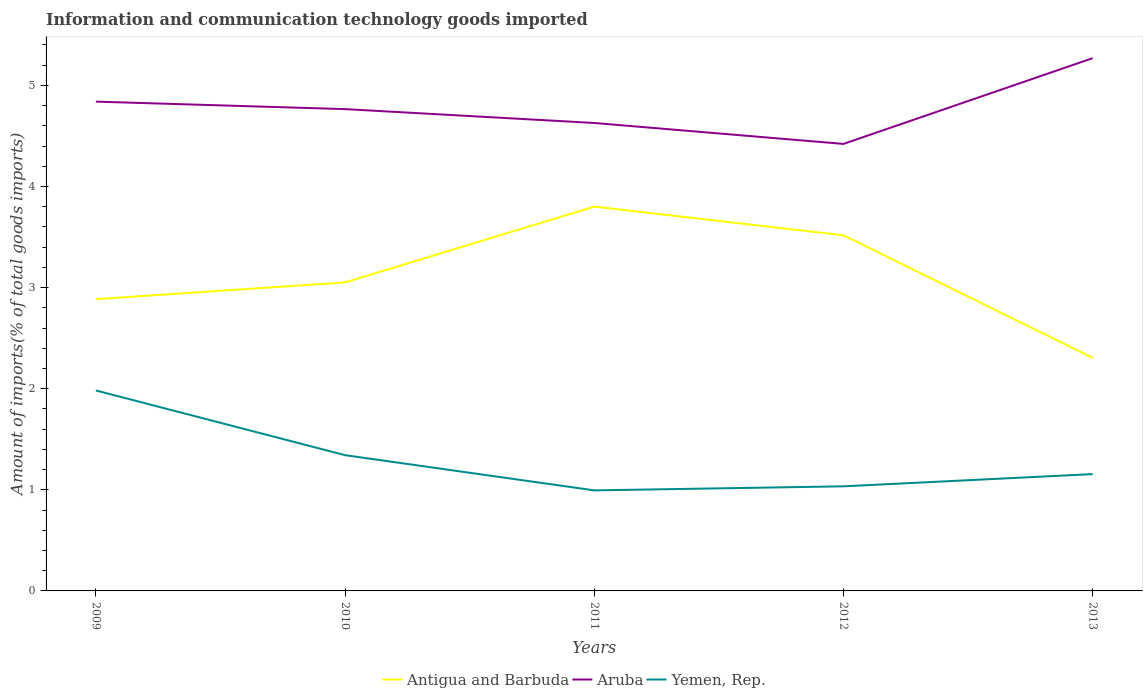Across all years, what is the maximum amount of goods imported in Yemen, Rep.?
Your answer should be very brief. 0.99. In which year was the amount of goods imported in Antigua and Barbuda maximum?
Offer a terse response. 2013. What is the total amount of goods imported in Aruba in the graph?
Make the answer very short. 0.14. What is the difference between the highest and the second highest amount of goods imported in Yemen, Rep.?
Ensure brevity in your answer.  0.99. Are the values on the major ticks of Y-axis written in scientific E-notation?
Provide a succinct answer. No. Does the graph contain grids?
Provide a succinct answer. No. How are the legend labels stacked?
Your response must be concise. Horizontal. What is the title of the graph?
Keep it short and to the point. Information and communication technology goods imported. Does "Iraq" appear as one of the legend labels in the graph?
Give a very brief answer. No. What is the label or title of the Y-axis?
Your answer should be very brief. Amount of imports(% of total goods imports). What is the Amount of imports(% of total goods imports) of Antigua and Barbuda in 2009?
Keep it short and to the point. 2.89. What is the Amount of imports(% of total goods imports) in Aruba in 2009?
Offer a very short reply. 4.84. What is the Amount of imports(% of total goods imports) in Yemen, Rep. in 2009?
Give a very brief answer. 1.98. What is the Amount of imports(% of total goods imports) of Antigua and Barbuda in 2010?
Offer a very short reply. 3.05. What is the Amount of imports(% of total goods imports) of Aruba in 2010?
Your response must be concise. 4.76. What is the Amount of imports(% of total goods imports) in Yemen, Rep. in 2010?
Offer a terse response. 1.34. What is the Amount of imports(% of total goods imports) in Antigua and Barbuda in 2011?
Give a very brief answer. 3.8. What is the Amount of imports(% of total goods imports) in Aruba in 2011?
Offer a very short reply. 4.63. What is the Amount of imports(% of total goods imports) in Yemen, Rep. in 2011?
Your answer should be compact. 0.99. What is the Amount of imports(% of total goods imports) of Antigua and Barbuda in 2012?
Offer a terse response. 3.52. What is the Amount of imports(% of total goods imports) of Aruba in 2012?
Your answer should be very brief. 4.42. What is the Amount of imports(% of total goods imports) of Yemen, Rep. in 2012?
Offer a very short reply. 1.03. What is the Amount of imports(% of total goods imports) in Antigua and Barbuda in 2013?
Give a very brief answer. 2.31. What is the Amount of imports(% of total goods imports) of Aruba in 2013?
Offer a terse response. 5.27. What is the Amount of imports(% of total goods imports) in Yemen, Rep. in 2013?
Provide a succinct answer. 1.16. Across all years, what is the maximum Amount of imports(% of total goods imports) of Antigua and Barbuda?
Provide a succinct answer. 3.8. Across all years, what is the maximum Amount of imports(% of total goods imports) of Aruba?
Give a very brief answer. 5.27. Across all years, what is the maximum Amount of imports(% of total goods imports) of Yemen, Rep.?
Your answer should be very brief. 1.98. Across all years, what is the minimum Amount of imports(% of total goods imports) in Antigua and Barbuda?
Provide a short and direct response. 2.31. Across all years, what is the minimum Amount of imports(% of total goods imports) of Aruba?
Your response must be concise. 4.42. Across all years, what is the minimum Amount of imports(% of total goods imports) in Yemen, Rep.?
Your answer should be very brief. 0.99. What is the total Amount of imports(% of total goods imports) of Antigua and Barbuda in the graph?
Provide a succinct answer. 15.56. What is the total Amount of imports(% of total goods imports) of Aruba in the graph?
Offer a terse response. 23.92. What is the total Amount of imports(% of total goods imports) in Yemen, Rep. in the graph?
Ensure brevity in your answer.  6.51. What is the difference between the Amount of imports(% of total goods imports) of Antigua and Barbuda in 2009 and that in 2010?
Your answer should be very brief. -0.17. What is the difference between the Amount of imports(% of total goods imports) of Aruba in 2009 and that in 2010?
Your answer should be compact. 0.07. What is the difference between the Amount of imports(% of total goods imports) in Yemen, Rep. in 2009 and that in 2010?
Your response must be concise. 0.64. What is the difference between the Amount of imports(% of total goods imports) in Antigua and Barbuda in 2009 and that in 2011?
Your answer should be very brief. -0.92. What is the difference between the Amount of imports(% of total goods imports) of Aruba in 2009 and that in 2011?
Offer a terse response. 0.21. What is the difference between the Amount of imports(% of total goods imports) in Antigua and Barbuda in 2009 and that in 2012?
Your answer should be very brief. -0.63. What is the difference between the Amount of imports(% of total goods imports) in Aruba in 2009 and that in 2012?
Your answer should be very brief. 0.42. What is the difference between the Amount of imports(% of total goods imports) of Yemen, Rep. in 2009 and that in 2012?
Give a very brief answer. 0.95. What is the difference between the Amount of imports(% of total goods imports) in Antigua and Barbuda in 2009 and that in 2013?
Your response must be concise. 0.58. What is the difference between the Amount of imports(% of total goods imports) in Aruba in 2009 and that in 2013?
Your response must be concise. -0.43. What is the difference between the Amount of imports(% of total goods imports) in Yemen, Rep. in 2009 and that in 2013?
Your answer should be very brief. 0.83. What is the difference between the Amount of imports(% of total goods imports) in Antigua and Barbuda in 2010 and that in 2011?
Keep it short and to the point. -0.75. What is the difference between the Amount of imports(% of total goods imports) in Aruba in 2010 and that in 2011?
Ensure brevity in your answer.  0.14. What is the difference between the Amount of imports(% of total goods imports) in Yemen, Rep. in 2010 and that in 2011?
Provide a succinct answer. 0.35. What is the difference between the Amount of imports(% of total goods imports) in Antigua and Barbuda in 2010 and that in 2012?
Give a very brief answer. -0.47. What is the difference between the Amount of imports(% of total goods imports) of Aruba in 2010 and that in 2012?
Your response must be concise. 0.34. What is the difference between the Amount of imports(% of total goods imports) of Yemen, Rep. in 2010 and that in 2012?
Provide a succinct answer. 0.31. What is the difference between the Amount of imports(% of total goods imports) in Antigua and Barbuda in 2010 and that in 2013?
Offer a very short reply. 0.75. What is the difference between the Amount of imports(% of total goods imports) in Aruba in 2010 and that in 2013?
Your answer should be compact. -0.5. What is the difference between the Amount of imports(% of total goods imports) of Yemen, Rep. in 2010 and that in 2013?
Provide a succinct answer. 0.19. What is the difference between the Amount of imports(% of total goods imports) of Antigua and Barbuda in 2011 and that in 2012?
Offer a very short reply. 0.28. What is the difference between the Amount of imports(% of total goods imports) of Aruba in 2011 and that in 2012?
Your answer should be compact. 0.21. What is the difference between the Amount of imports(% of total goods imports) in Yemen, Rep. in 2011 and that in 2012?
Provide a succinct answer. -0.04. What is the difference between the Amount of imports(% of total goods imports) in Antigua and Barbuda in 2011 and that in 2013?
Offer a terse response. 1.5. What is the difference between the Amount of imports(% of total goods imports) in Aruba in 2011 and that in 2013?
Provide a succinct answer. -0.64. What is the difference between the Amount of imports(% of total goods imports) of Yemen, Rep. in 2011 and that in 2013?
Provide a succinct answer. -0.16. What is the difference between the Amount of imports(% of total goods imports) of Antigua and Barbuda in 2012 and that in 2013?
Your answer should be very brief. 1.21. What is the difference between the Amount of imports(% of total goods imports) of Aruba in 2012 and that in 2013?
Provide a succinct answer. -0.85. What is the difference between the Amount of imports(% of total goods imports) in Yemen, Rep. in 2012 and that in 2013?
Make the answer very short. -0.12. What is the difference between the Amount of imports(% of total goods imports) of Antigua and Barbuda in 2009 and the Amount of imports(% of total goods imports) of Aruba in 2010?
Provide a succinct answer. -1.88. What is the difference between the Amount of imports(% of total goods imports) of Antigua and Barbuda in 2009 and the Amount of imports(% of total goods imports) of Yemen, Rep. in 2010?
Provide a short and direct response. 1.54. What is the difference between the Amount of imports(% of total goods imports) of Aruba in 2009 and the Amount of imports(% of total goods imports) of Yemen, Rep. in 2010?
Offer a terse response. 3.5. What is the difference between the Amount of imports(% of total goods imports) of Antigua and Barbuda in 2009 and the Amount of imports(% of total goods imports) of Aruba in 2011?
Your answer should be very brief. -1.74. What is the difference between the Amount of imports(% of total goods imports) in Antigua and Barbuda in 2009 and the Amount of imports(% of total goods imports) in Yemen, Rep. in 2011?
Offer a terse response. 1.89. What is the difference between the Amount of imports(% of total goods imports) of Aruba in 2009 and the Amount of imports(% of total goods imports) of Yemen, Rep. in 2011?
Your answer should be very brief. 3.84. What is the difference between the Amount of imports(% of total goods imports) in Antigua and Barbuda in 2009 and the Amount of imports(% of total goods imports) in Aruba in 2012?
Your answer should be compact. -1.54. What is the difference between the Amount of imports(% of total goods imports) in Antigua and Barbuda in 2009 and the Amount of imports(% of total goods imports) in Yemen, Rep. in 2012?
Give a very brief answer. 1.85. What is the difference between the Amount of imports(% of total goods imports) of Aruba in 2009 and the Amount of imports(% of total goods imports) of Yemen, Rep. in 2012?
Offer a very short reply. 3.8. What is the difference between the Amount of imports(% of total goods imports) in Antigua and Barbuda in 2009 and the Amount of imports(% of total goods imports) in Aruba in 2013?
Offer a very short reply. -2.38. What is the difference between the Amount of imports(% of total goods imports) of Antigua and Barbuda in 2009 and the Amount of imports(% of total goods imports) of Yemen, Rep. in 2013?
Your answer should be very brief. 1.73. What is the difference between the Amount of imports(% of total goods imports) of Aruba in 2009 and the Amount of imports(% of total goods imports) of Yemen, Rep. in 2013?
Provide a short and direct response. 3.68. What is the difference between the Amount of imports(% of total goods imports) of Antigua and Barbuda in 2010 and the Amount of imports(% of total goods imports) of Aruba in 2011?
Ensure brevity in your answer.  -1.58. What is the difference between the Amount of imports(% of total goods imports) of Antigua and Barbuda in 2010 and the Amount of imports(% of total goods imports) of Yemen, Rep. in 2011?
Offer a very short reply. 2.06. What is the difference between the Amount of imports(% of total goods imports) in Aruba in 2010 and the Amount of imports(% of total goods imports) in Yemen, Rep. in 2011?
Ensure brevity in your answer.  3.77. What is the difference between the Amount of imports(% of total goods imports) in Antigua and Barbuda in 2010 and the Amount of imports(% of total goods imports) in Aruba in 2012?
Make the answer very short. -1.37. What is the difference between the Amount of imports(% of total goods imports) in Antigua and Barbuda in 2010 and the Amount of imports(% of total goods imports) in Yemen, Rep. in 2012?
Offer a terse response. 2.02. What is the difference between the Amount of imports(% of total goods imports) in Aruba in 2010 and the Amount of imports(% of total goods imports) in Yemen, Rep. in 2012?
Your response must be concise. 3.73. What is the difference between the Amount of imports(% of total goods imports) of Antigua and Barbuda in 2010 and the Amount of imports(% of total goods imports) of Aruba in 2013?
Offer a very short reply. -2.22. What is the difference between the Amount of imports(% of total goods imports) in Antigua and Barbuda in 2010 and the Amount of imports(% of total goods imports) in Yemen, Rep. in 2013?
Offer a terse response. 1.9. What is the difference between the Amount of imports(% of total goods imports) in Aruba in 2010 and the Amount of imports(% of total goods imports) in Yemen, Rep. in 2013?
Your answer should be compact. 3.61. What is the difference between the Amount of imports(% of total goods imports) in Antigua and Barbuda in 2011 and the Amount of imports(% of total goods imports) in Aruba in 2012?
Ensure brevity in your answer.  -0.62. What is the difference between the Amount of imports(% of total goods imports) in Antigua and Barbuda in 2011 and the Amount of imports(% of total goods imports) in Yemen, Rep. in 2012?
Ensure brevity in your answer.  2.77. What is the difference between the Amount of imports(% of total goods imports) of Aruba in 2011 and the Amount of imports(% of total goods imports) of Yemen, Rep. in 2012?
Your answer should be very brief. 3.59. What is the difference between the Amount of imports(% of total goods imports) of Antigua and Barbuda in 2011 and the Amount of imports(% of total goods imports) of Aruba in 2013?
Your answer should be compact. -1.47. What is the difference between the Amount of imports(% of total goods imports) of Antigua and Barbuda in 2011 and the Amount of imports(% of total goods imports) of Yemen, Rep. in 2013?
Offer a very short reply. 2.65. What is the difference between the Amount of imports(% of total goods imports) in Aruba in 2011 and the Amount of imports(% of total goods imports) in Yemen, Rep. in 2013?
Ensure brevity in your answer.  3.47. What is the difference between the Amount of imports(% of total goods imports) in Antigua and Barbuda in 2012 and the Amount of imports(% of total goods imports) in Aruba in 2013?
Ensure brevity in your answer.  -1.75. What is the difference between the Amount of imports(% of total goods imports) in Antigua and Barbuda in 2012 and the Amount of imports(% of total goods imports) in Yemen, Rep. in 2013?
Give a very brief answer. 2.36. What is the difference between the Amount of imports(% of total goods imports) of Aruba in 2012 and the Amount of imports(% of total goods imports) of Yemen, Rep. in 2013?
Give a very brief answer. 3.27. What is the average Amount of imports(% of total goods imports) of Antigua and Barbuda per year?
Ensure brevity in your answer.  3.11. What is the average Amount of imports(% of total goods imports) in Aruba per year?
Offer a terse response. 4.78. What is the average Amount of imports(% of total goods imports) in Yemen, Rep. per year?
Provide a short and direct response. 1.3. In the year 2009, what is the difference between the Amount of imports(% of total goods imports) in Antigua and Barbuda and Amount of imports(% of total goods imports) in Aruba?
Your response must be concise. -1.95. In the year 2009, what is the difference between the Amount of imports(% of total goods imports) in Antigua and Barbuda and Amount of imports(% of total goods imports) in Yemen, Rep.?
Offer a terse response. 0.9. In the year 2009, what is the difference between the Amount of imports(% of total goods imports) in Aruba and Amount of imports(% of total goods imports) in Yemen, Rep.?
Your response must be concise. 2.86. In the year 2010, what is the difference between the Amount of imports(% of total goods imports) in Antigua and Barbuda and Amount of imports(% of total goods imports) in Aruba?
Provide a short and direct response. -1.71. In the year 2010, what is the difference between the Amount of imports(% of total goods imports) in Antigua and Barbuda and Amount of imports(% of total goods imports) in Yemen, Rep.?
Keep it short and to the point. 1.71. In the year 2010, what is the difference between the Amount of imports(% of total goods imports) of Aruba and Amount of imports(% of total goods imports) of Yemen, Rep.?
Provide a succinct answer. 3.42. In the year 2011, what is the difference between the Amount of imports(% of total goods imports) in Antigua and Barbuda and Amount of imports(% of total goods imports) in Aruba?
Make the answer very short. -0.83. In the year 2011, what is the difference between the Amount of imports(% of total goods imports) in Antigua and Barbuda and Amount of imports(% of total goods imports) in Yemen, Rep.?
Keep it short and to the point. 2.81. In the year 2011, what is the difference between the Amount of imports(% of total goods imports) in Aruba and Amount of imports(% of total goods imports) in Yemen, Rep.?
Offer a very short reply. 3.63. In the year 2012, what is the difference between the Amount of imports(% of total goods imports) in Antigua and Barbuda and Amount of imports(% of total goods imports) in Aruba?
Provide a succinct answer. -0.9. In the year 2012, what is the difference between the Amount of imports(% of total goods imports) in Antigua and Barbuda and Amount of imports(% of total goods imports) in Yemen, Rep.?
Ensure brevity in your answer.  2.48. In the year 2012, what is the difference between the Amount of imports(% of total goods imports) in Aruba and Amount of imports(% of total goods imports) in Yemen, Rep.?
Offer a terse response. 3.39. In the year 2013, what is the difference between the Amount of imports(% of total goods imports) in Antigua and Barbuda and Amount of imports(% of total goods imports) in Aruba?
Your response must be concise. -2.96. In the year 2013, what is the difference between the Amount of imports(% of total goods imports) of Antigua and Barbuda and Amount of imports(% of total goods imports) of Yemen, Rep.?
Offer a very short reply. 1.15. In the year 2013, what is the difference between the Amount of imports(% of total goods imports) in Aruba and Amount of imports(% of total goods imports) in Yemen, Rep.?
Offer a very short reply. 4.11. What is the ratio of the Amount of imports(% of total goods imports) in Antigua and Barbuda in 2009 to that in 2010?
Keep it short and to the point. 0.95. What is the ratio of the Amount of imports(% of total goods imports) of Aruba in 2009 to that in 2010?
Keep it short and to the point. 1.02. What is the ratio of the Amount of imports(% of total goods imports) of Yemen, Rep. in 2009 to that in 2010?
Your answer should be very brief. 1.48. What is the ratio of the Amount of imports(% of total goods imports) of Antigua and Barbuda in 2009 to that in 2011?
Your response must be concise. 0.76. What is the ratio of the Amount of imports(% of total goods imports) of Aruba in 2009 to that in 2011?
Provide a short and direct response. 1.05. What is the ratio of the Amount of imports(% of total goods imports) in Yemen, Rep. in 2009 to that in 2011?
Offer a very short reply. 1.99. What is the ratio of the Amount of imports(% of total goods imports) of Antigua and Barbuda in 2009 to that in 2012?
Offer a terse response. 0.82. What is the ratio of the Amount of imports(% of total goods imports) in Aruba in 2009 to that in 2012?
Give a very brief answer. 1.09. What is the ratio of the Amount of imports(% of total goods imports) in Yemen, Rep. in 2009 to that in 2012?
Ensure brevity in your answer.  1.92. What is the ratio of the Amount of imports(% of total goods imports) in Antigua and Barbuda in 2009 to that in 2013?
Offer a very short reply. 1.25. What is the ratio of the Amount of imports(% of total goods imports) in Aruba in 2009 to that in 2013?
Your answer should be very brief. 0.92. What is the ratio of the Amount of imports(% of total goods imports) in Yemen, Rep. in 2009 to that in 2013?
Offer a very short reply. 1.72. What is the ratio of the Amount of imports(% of total goods imports) in Antigua and Barbuda in 2010 to that in 2011?
Make the answer very short. 0.8. What is the ratio of the Amount of imports(% of total goods imports) in Aruba in 2010 to that in 2011?
Offer a terse response. 1.03. What is the ratio of the Amount of imports(% of total goods imports) in Yemen, Rep. in 2010 to that in 2011?
Your response must be concise. 1.35. What is the ratio of the Amount of imports(% of total goods imports) of Antigua and Barbuda in 2010 to that in 2012?
Keep it short and to the point. 0.87. What is the ratio of the Amount of imports(% of total goods imports) in Aruba in 2010 to that in 2012?
Give a very brief answer. 1.08. What is the ratio of the Amount of imports(% of total goods imports) in Yemen, Rep. in 2010 to that in 2012?
Your response must be concise. 1.3. What is the ratio of the Amount of imports(% of total goods imports) in Antigua and Barbuda in 2010 to that in 2013?
Offer a very short reply. 1.32. What is the ratio of the Amount of imports(% of total goods imports) of Aruba in 2010 to that in 2013?
Keep it short and to the point. 0.9. What is the ratio of the Amount of imports(% of total goods imports) of Yemen, Rep. in 2010 to that in 2013?
Ensure brevity in your answer.  1.16. What is the ratio of the Amount of imports(% of total goods imports) in Antigua and Barbuda in 2011 to that in 2012?
Provide a succinct answer. 1.08. What is the ratio of the Amount of imports(% of total goods imports) in Aruba in 2011 to that in 2012?
Provide a short and direct response. 1.05. What is the ratio of the Amount of imports(% of total goods imports) of Yemen, Rep. in 2011 to that in 2012?
Your answer should be very brief. 0.96. What is the ratio of the Amount of imports(% of total goods imports) of Antigua and Barbuda in 2011 to that in 2013?
Keep it short and to the point. 1.65. What is the ratio of the Amount of imports(% of total goods imports) of Aruba in 2011 to that in 2013?
Provide a succinct answer. 0.88. What is the ratio of the Amount of imports(% of total goods imports) of Yemen, Rep. in 2011 to that in 2013?
Provide a short and direct response. 0.86. What is the ratio of the Amount of imports(% of total goods imports) of Antigua and Barbuda in 2012 to that in 2013?
Offer a terse response. 1.53. What is the ratio of the Amount of imports(% of total goods imports) in Aruba in 2012 to that in 2013?
Provide a succinct answer. 0.84. What is the ratio of the Amount of imports(% of total goods imports) of Yemen, Rep. in 2012 to that in 2013?
Offer a very short reply. 0.9. What is the difference between the highest and the second highest Amount of imports(% of total goods imports) in Antigua and Barbuda?
Offer a very short reply. 0.28. What is the difference between the highest and the second highest Amount of imports(% of total goods imports) of Aruba?
Offer a terse response. 0.43. What is the difference between the highest and the second highest Amount of imports(% of total goods imports) of Yemen, Rep.?
Your response must be concise. 0.64. What is the difference between the highest and the lowest Amount of imports(% of total goods imports) in Antigua and Barbuda?
Provide a short and direct response. 1.5. What is the difference between the highest and the lowest Amount of imports(% of total goods imports) in Aruba?
Give a very brief answer. 0.85. 